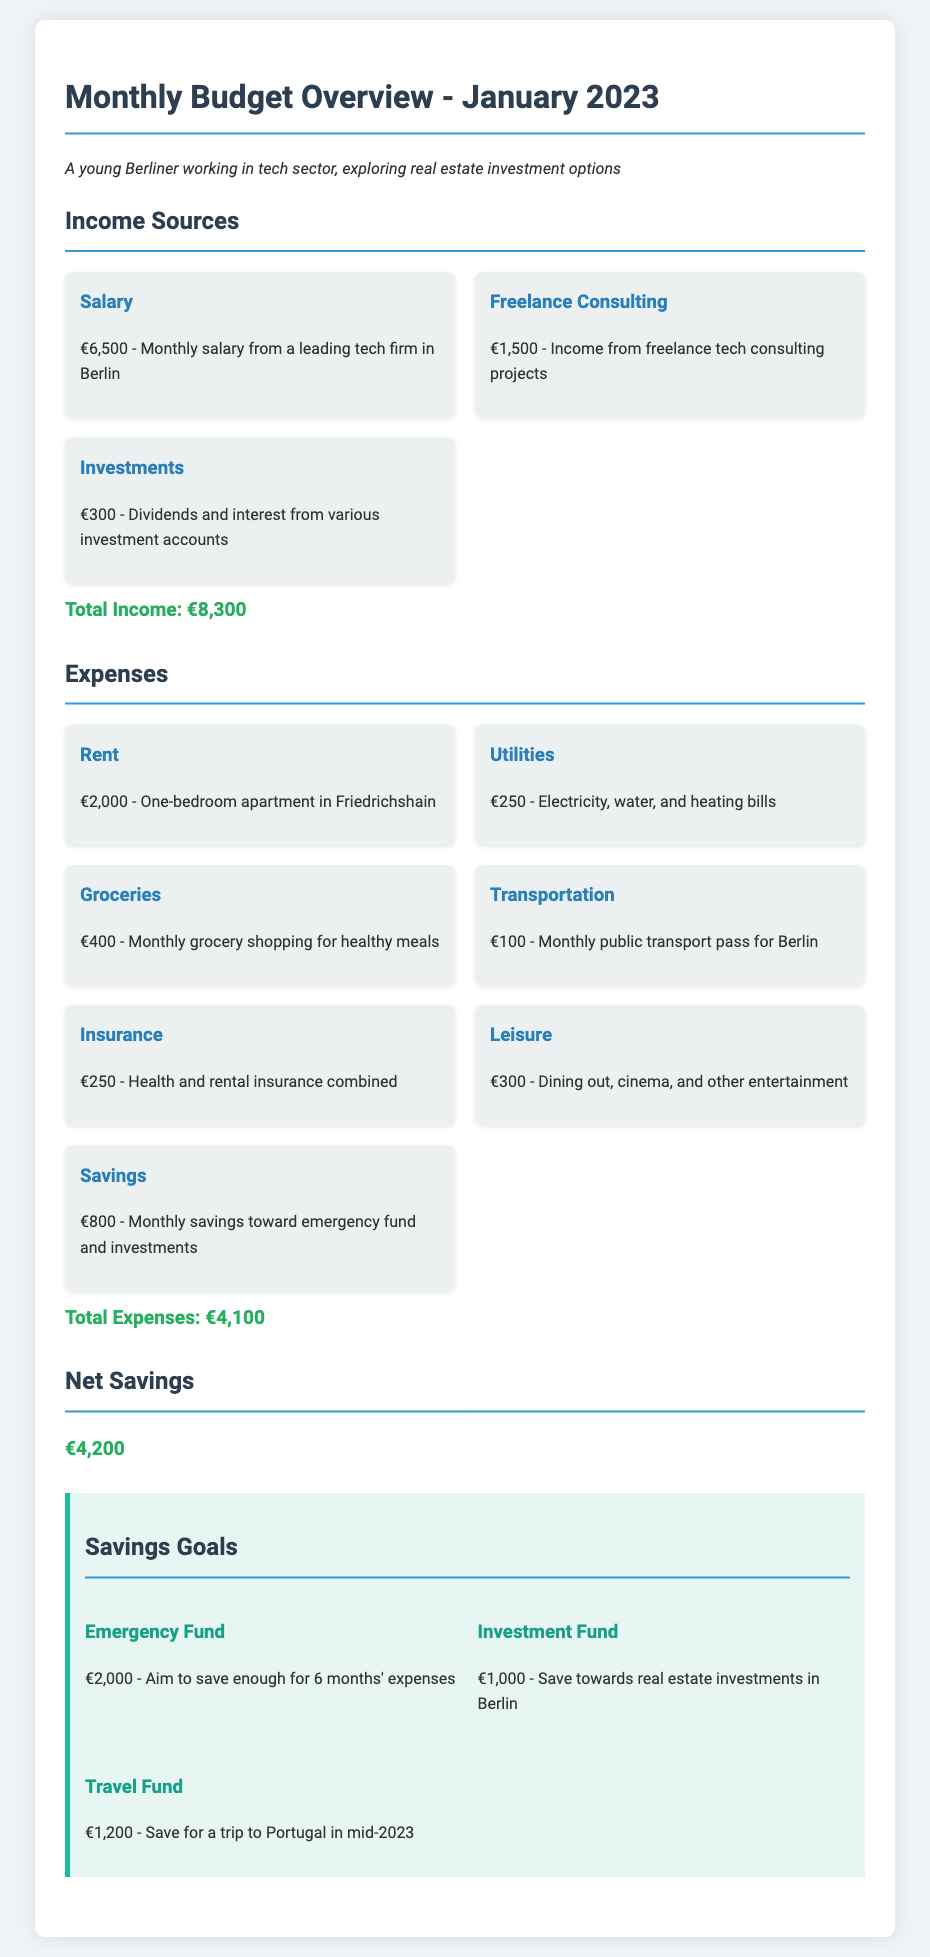What is the total income for January 2023? The total income is the sum of all income sources listed in the document: Salary, Freelance Consulting, and Investments.
Answer: €8,300 What is the amount spent on rent? The document specifies the rent cost for a one-bedroom apartment in Friedrichshain.
Answer: €2,000 How much is allocated for leisure expenses? The leisure expenses section indicates the total spent on dining out, cinema, and other entertainment.
Answer: €300 What portion of the income is saved as net savings? Net savings is determined by subtracting total expenses from total income.
Answer: €4,200 What is the goal amount for the emergency fund? The savings goals section specifies the aim for the emergency fund.
Answer: €2,000 How much is spent on utilities? The document provides a breakdown of monthly expenses, including utilities.
Answer: €250 What are the total expenses for January 2023? Total expenses are clearly listed as part of the monthly budget overview.
Answer: €4,100 How much is planned for the travel fund? The travel fund goal amount is mentioned in the savings goals section of the document.
Answer: €1,200 What percentage of the income is allocated to savings? Savings amount is calculated out of the total income, derived from the values listed.
Answer: Approximately 9.64% 